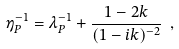Convert formula to latex. <formula><loc_0><loc_0><loc_500><loc_500>\eta ^ { - 1 } _ { P } = \lambda ^ { - 1 } _ { P } + \frac { 1 - 2 k } { ( 1 - i k ) ^ { - 2 } } \ ,</formula> 